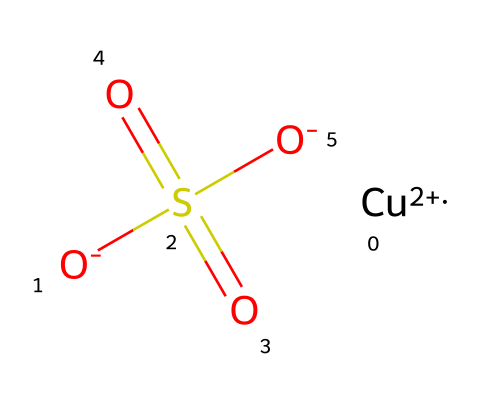What is the oxidation state of copper in this structure? The oxidation state of copper is determined by looking at the charge indicated next to the copper atom. In this case, it is shown as +2.
Answer: +2 How many oxygen atoms are present in this molecule? The SMILES representation indicates that there are four oxygen atoms: two in the sulfate group and two as part of the charges.
Answer: four What is the molecular formula of this copper-based fungicide? To determine the molecular formula, we count the number of each type of atom present in the SMILES: Cu, O, S. This gives us CuO4S.
Answer: CuO4S What functional group is present in this chemical? The functional group can be identified as the sulfate group, which contains sulfur and oxygen atoms in the "-S(=O)(=O)" part of the SMILES representation.
Answer: sulfate How many total atoms are there in this compound? The total number of atoms can be calculated by adding the individual counts of each element present: 1 copper, 1 sulfur, and 4 oxygen yields a total of 6 atoms.
Answer: six What type of pesticide is inferred from the presence of copper in the structure? Copper-based fungicides, such as the one represented, are commonly used to control fungal diseases in crops, indicating its type.
Answer: fungicide Which part of the structure provides its fungicidal properties? The copper ion is known for its antimicrobial properties, which contribute to the chemical's effectiveness as a fungicide.
Answer: copper ion 